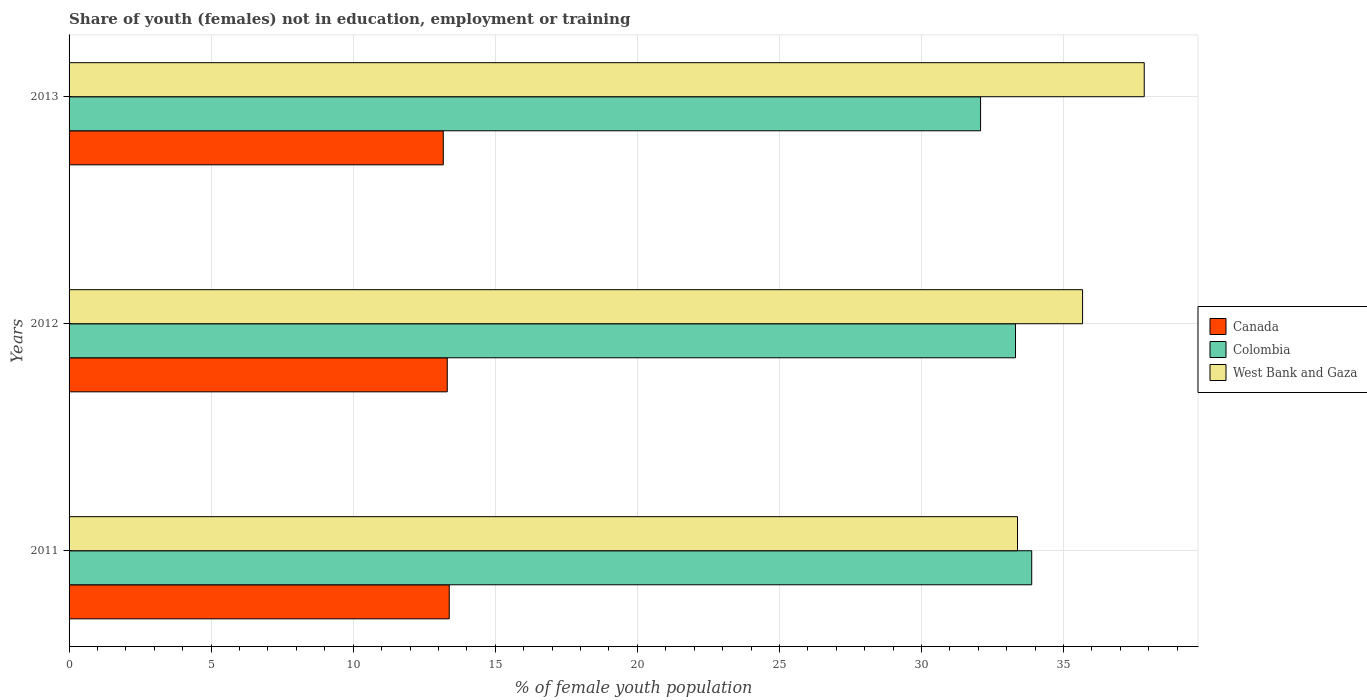How many groups of bars are there?
Your answer should be compact. 3. Are the number of bars per tick equal to the number of legend labels?
Provide a short and direct response. Yes. Are the number of bars on each tick of the Y-axis equal?
Ensure brevity in your answer.  Yes. How many bars are there on the 3rd tick from the top?
Offer a terse response. 3. How many bars are there on the 2nd tick from the bottom?
Your answer should be very brief. 3. What is the label of the 1st group of bars from the top?
Your answer should be very brief. 2013. In how many cases, is the number of bars for a given year not equal to the number of legend labels?
Give a very brief answer. 0. What is the percentage of unemployed female population in in West Bank and Gaza in 2012?
Offer a very short reply. 35.67. Across all years, what is the maximum percentage of unemployed female population in in West Bank and Gaza?
Provide a succinct answer. 37.84. Across all years, what is the minimum percentage of unemployed female population in in West Bank and Gaza?
Provide a succinct answer. 33.38. In which year was the percentage of unemployed female population in in Canada maximum?
Give a very brief answer. 2011. In which year was the percentage of unemployed female population in in Canada minimum?
Your response must be concise. 2013. What is the total percentage of unemployed female population in in Canada in the graph?
Provide a short and direct response. 39.86. What is the difference between the percentage of unemployed female population in in Canada in 2011 and that in 2013?
Make the answer very short. 0.21. What is the difference between the percentage of unemployed female population in in West Bank and Gaza in 2011 and the percentage of unemployed female population in in Colombia in 2012?
Offer a terse response. 0.07. What is the average percentage of unemployed female population in in Colombia per year?
Make the answer very short. 33.09. In the year 2011, what is the difference between the percentage of unemployed female population in in Canada and percentage of unemployed female population in in West Bank and Gaza?
Your response must be concise. -20. What is the ratio of the percentage of unemployed female population in in Colombia in 2011 to that in 2013?
Ensure brevity in your answer.  1.06. Is the percentage of unemployed female population in in Colombia in 2012 less than that in 2013?
Your answer should be very brief. No. What is the difference between the highest and the second highest percentage of unemployed female population in in Canada?
Ensure brevity in your answer.  0.07. What is the difference between the highest and the lowest percentage of unemployed female population in in Canada?
Offer a terse response. 0.21. Is the sum of the percentage of unemployed female population in in West Bank and Gaza in 2011 and 2012 greater than the maximum percentage of unemployed female population in in Colombia across all years?
Offer a very short reply. Yes. What does the 3rd bar from the top in 2012 represents?
Provide a short and direct response. Canada. Are all the bars in the graph horizontal?
Provide a short and direct response. Yes. How many years are there in the graph?
Your answer should be very brief. 3. What is the difference between two consecutive major ticks on the X-axis?
Your response must be concise. 5. Are the values on the major ticks of X-axis written in scientific E-notation?
Your answer should be compact. No. Does the graph contain any zero values?
Offer a terse response. No. How many legend labels are there?
Provide a succinct answer. 3. What is the title of the graph?
Give a very brief answer. Share of youth (females) not in education, employment or training. Does "Bolivia" appear as one of the legend labels in the graph?
Ensure brevity in your answer.  No. What is the label or title of the X-axis?
Offer a very short reply. % of female youth population. What is the label or title of the Y-axis?
Give a very brief answer. Years. What is the % of female youth population in Canada in 2011?
Make the answer very short. 13.38. What is the % of female youth population in Colombia in 2011?
Offer a very short reply. 33.88. What is the % of female youth population in West Bank and Gaza in 2011?
Provide a succinct answer. 33.38. What is the % of female youth population of Canada in 2012?
Provide a succinct answer. 13.31. What is the % of female youth population in Colombia in 2012?
Keep it short and to the point. 33.31. What is the % of female youth population of West Bank and Gaza in 2012?
Your answer should be compact. 35.67. What is the % of female youth population in Canada in 2013?
Provide a short and direct response. 13.17. What is the % of female youth population in Colombia in 2013?
Make the answer very short. 32.08. What is the % of female youth population of West Bank and Gaza in 2013?
Ensure brevity in your answer.  37.84. Across all years, what is the maximum % of female youth population in Canada?
Offer a terse response. 13.38. Across all years, what is the maximum % of female youth population in Colombia?
Offer a very short reply. 33.88. Across all years, what is the maximum % of female youth population in West Bank and Gaza?
Your response must be concise. 37.84. Across all years, what is the minimum % of female youth population of Canada?
Offer a terse response. 13.17. Across all years, what is the minimum % of female youth population of Colombia?
Keep it short and to the point. 32.08. Across all years, what is the minimum % of female youth population in West Bank and Gaza?
Your response must be concise. 33.38. What is the total % of female youth population in Canada in the graph?
Your answer should be compact. 39.86. What is the total % of female youth population in Colombia in the graph?
Offer a very short reply. 99.27. What is the total % of female youth population in West Bank and Gaza in the graph?
Your response must be concise. 106.89. What is the difference between the % of female youth population of Canada in 2011 and that in 2012?
Keep it short and to the point. 0.07. What is the difference between the % of female youth population of Colombia in 2011 and that in 2012?
Keep it short and to the point. 0.57. What is the difference between the % of female youth population of West Bank and Gaza in 2011 and that in 2012?
Provide a short and direct response. -2.29. What is the difference between the % of female youth population in Canada in 2011 and that in 2013?
Make the answer very short. 0.21. What is the difference between the % of female youth population of West Bank and Gaza in 2011 and that in 2013?
Provide a succinct answer. -4.46. What is the difference between the % of female youth population in Canada in 2012 and that in 2013?
Provide a short and direct response. 0.14. What is the difference between the % of female youth population in Colombia in 2012 and that in 2013?
Give a very brief answer. 1.23. What is the difference between the % of female youth population in West Bank and Gaza in 2012 and that in 2013?
Give a very brief answer. -2.17. What is the difference between the % of female youth population of Canada in 2011 and the % of female youth population of Colombia in 2012?
Provide a short and direct response. -19.93. What is the difference between the % of female youth population in Canada in 2011 and the % of female youth population in West Bank and Gaza in 2012?
Offer a terse response. -22.29. What is the difference between the % of female youth population of Colombia in 2011 and the % of female youth population of West Bank and Gaza in 2012?
Your response must be concise. -1.79. What is the difference between the % of female youth population of Canada in 2011 and the % of female youth population of Colombia in 2013?
Ensure brevity in your answer.  -18.7. What is the difference between the % of female youth population in Canada in 2011 and the % of female youth population in West Bank and Gaza in 2013?
Ensure brevity in your answer.  -24.46. What is the difference between the % of female youth population in Colombia in 2011 and the % of female youth population in West Bank and Gaza in 2013?
Your response must be concise. -3.96. What is the difference between the % of female youth population in Canada in 2012 and the % of female youth population in Colombia in 2013?
Provide a succinct answer. -18.77. What is the difference between the % of female youth population of Canada in 2012 and the % of female youth population of West Bank and Gaza in 2013?
Keep it short and to the point. -24.53. What is the difference between the % of female youth population in Colombia in 2012 and the % of female youth population in West Bank and Gaza in 2013?
Make the answer very short. -4.53. What is the average % of female youth population in Canada per year?
Ensure brevity in your answer.  13.29. What is the average % of female youth population in Colombia per year?
Your answer should be very brief. 33.09. What is the average % of female youth population in West Bank and Gaza per year?
Offer a very short reply. 35.63. In the year 2011, what is the difference between the % of female youth population in Canada and % of female youth population in Colombia?
Make the answer very short. -20.5. In the year 2011, what is the difference between the % of female youth population of Colombia and % of female youth population of West Bank and Gaza?
Provide a short and direct response. 0.5. In the year 2012, what is the difference between the % of female youth population of Canada and % of female youth population of Colombia?
Make the answer very short. -20. In the year 2012, what is the difference between the % of female youth population of Canada and % of female youth population of West Bank and Gaza?
Give a very brief answer. -22.36. In the year 2012, what is the difference between the % of female youth population of Colombia and % of female youth population of West Bank and Gaza?
Make the answer very short. -2.36. In the year 2013, what is the difference between the % of female youth population in Canada and % of female youth population in Colombia?
Give a very brief answer. -18.91. In the year 2013, what is the difference between the % of female youth population of Canada and % of female youth population of West Bank and Gaza?
Your response must be concise. -24.67. In the year 2013, what is the difference between the % of female youth population in Colombia and % of female youth population in West Bank and Gaza?
Ensure brevity in your answer.  -5.76. What is the ratio of the % of female youth population in Colombia in 2011 to that in 2012?
Make the answer very short. 1.02. What is the ratio of the % of female youth population of West Bank and Gaza in 2011 to that in 2012?
Your answer should be compact. 0.94. What is the ratio of the % of female youth population in Canada in 2011 to that in 2013?
Your answer should be compact. 1.02. What is the ratio of the % of female youth population of Colombia in 2011 to that in 2013?
Provide a short and direct response. 1.06. What is the ratio of the % of female youth population in West Bank and Gaza in 2011 to that in 2013?
Keep it short and to the point. 0.88. What is the ratio of the % of female youth population of Canada in 2012 to that in 2013?
Provide a short and direct response. 1.01. What is the ratio of the % of female youth population of Colombia in 2012 to that in 2013?
Provide a succinct answer. 1.04. What is the ratio of the % of female youth population of West Bank and Gaza in 2012 to that in 2013?
Keep it short and to the point. 0.94. What is the difference between the highest and the second highest % of female youth population in Canada?
Ensure brevity in your answer.  0.07. What is the difference between the highest and the second highest % of female youth population of Colombia?
Your answer should be very brief. 0.57. What is the difference between the highest and the second highest % of female youth population of West Bank and Gaza?
Your answer should be very brief. 2.17. What is the difference between the highest and the lowest % of female youth population in Canada?
Your response must be concise. 0.21. What is the difference between the highest and the lowest % of female youth population in West Bank and Gaza?
Your response must be concise. 4.46. 